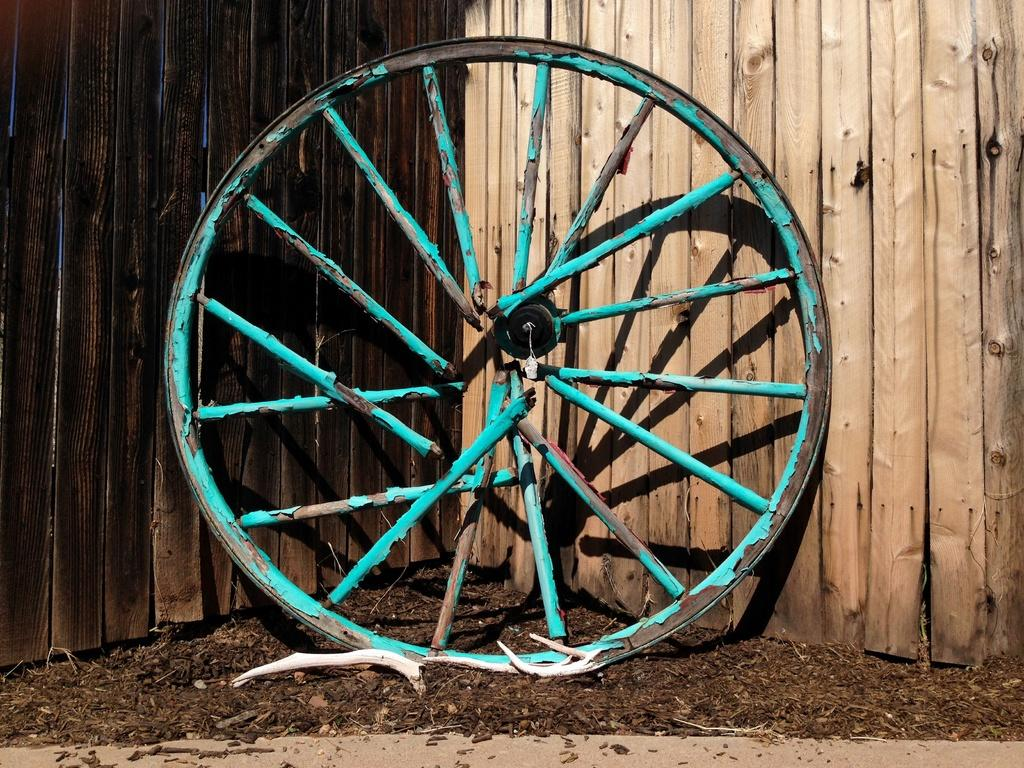What is the main object in the image? There is a wheel in the image. What type of material is used for the walls behind the wheel? The walls behind the wheel are made of wood. What can be seen on the floor at the bottom of the image? Wooden pieces are present on the floor at the bottom of the image. How many girls are holding lettuce in the image? There are no girls or lettuce present in the image. 